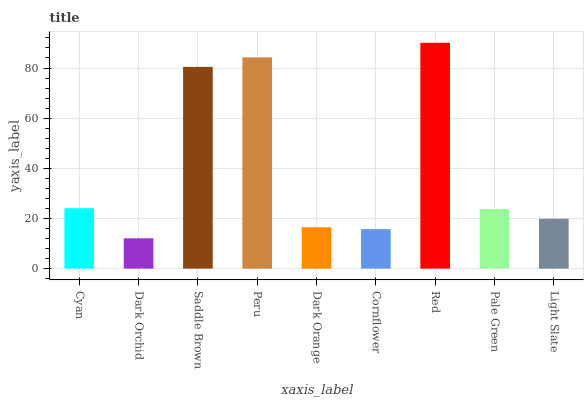Is Dark Orchid the minimum?
Answer yes or no. Yes. Is Red the maximum?
Answer yes or no. Yes. Is Saddle Brown the minimum?
Answer yes or no. No. Is Saddle Brown the maximum?
Answer yes or no. No. Is Saddle Brown greater than Dark Orchid?
Answer yes or no. Yes. Is Dark Orchid less than Saddle Brown?
Answer yes or no. Yes. Is Dark Orchid greater than Saddle Brown?
Answer yes or no. No. Is Saddle Brown less than Dark Orchid?
Answer yes or no. No. Is Pale Green the high median?
Answer yes or no. Yes. Is Pale Green the low median?
Answer yes or no. Yes. Is Cyan the high median?
Answer yes or no. No. Is Saddle Brown the low median?
Answer yes or no. No. 